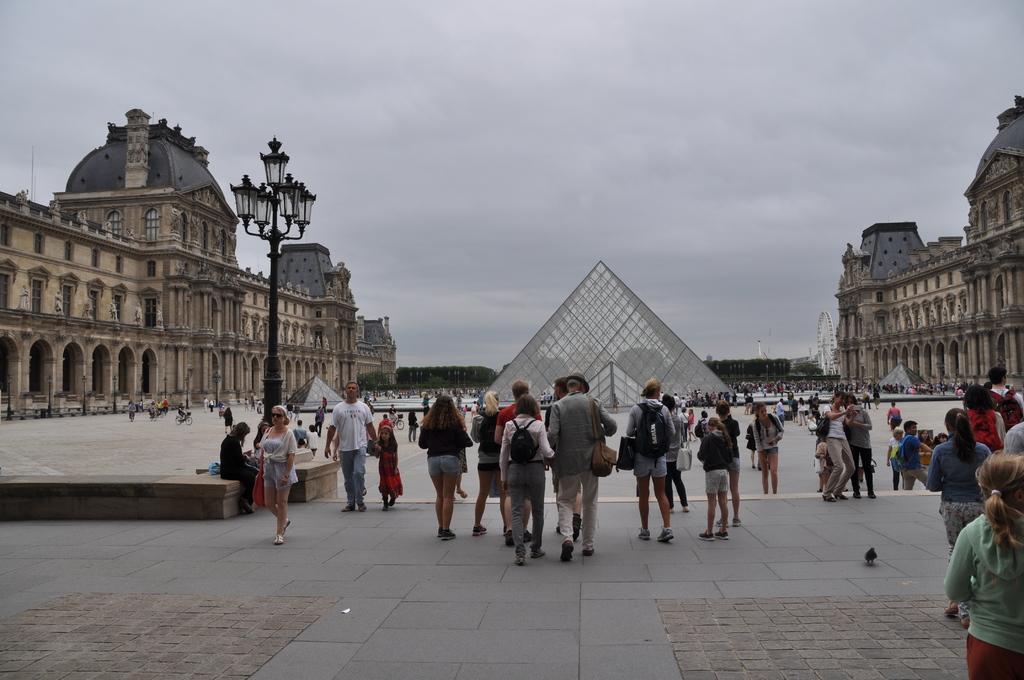In one or two sentences, can you explain what this image depicts? This is an outside view. Here I can see a crowd of people walking and standing on the ground. On the left side there is a pole and one person is sitting. In the background there are many trees, buildings and a structure. At the top of the image I can see the sky. On the right-side there is giant-wheel and a shed. 